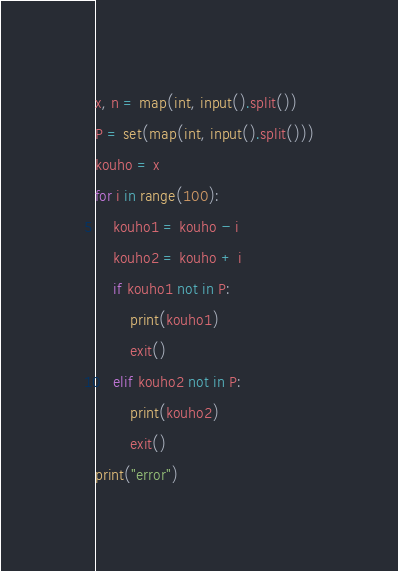Convert code to text. <code><loc_0><loc_0><loc_500><loc_500><_Python_>x, n = map(int, input().split())
P = set(map(int, input().split()))
kouho = x
for i in range(100):
    kouho1 = kouho - i
    kouho2 = kouho + i
    if kouho1 not in P:
        print(kouho1)
        exit()
    elif kouho2 not in P:
        print(kouho2)
        exit()
print("error")
</code> 